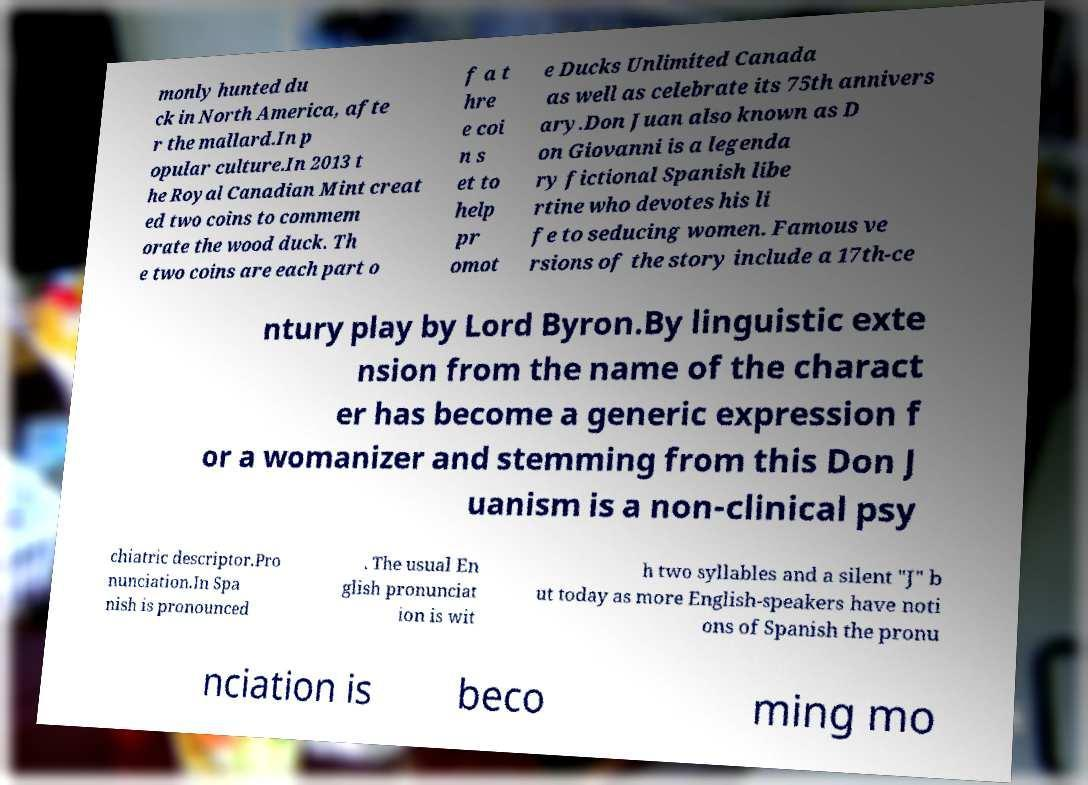Please identify and transcribe the text found in this image. monly hunted du ck in North America, afte r the mallard.In p opular culture.In 2013 t he Royal Canadian Mint creat ed two coins to commem orate the wood duck. Th e two coins are each part o f a t hre e coi n s et to help pr omot e Ducks Unlimited Canada as well as celebrate its 75th annivers ary.Don Juan also known as D on Giovanni is a legenda ry fictional Spanish libe rtine who devotes his li fe to seducing women. Famous ve rsions of the story include a 17th-ce ntury play by Lord Byron.By linguistic exte nsion from the name of the charact er has become a generic expression f or a womanizer and stemming from this Don J uanism is a non-clinical psy chiatric descriptor.Pro nunciation.In Spa nish is pronounced . The usual En glish pronunciat ion is wit h two syllables and a silent "J" b ut today as more English-speakers have noti ons of Spanish the pronu nciation is beco ming mo 